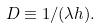Convert formula to latex. <formula><loc_0><loc_0><loc_500><loc_500>D \equiv 1 / ( \lambda h ) .</formula> 